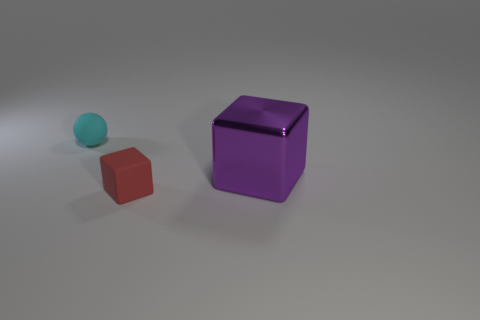How many matte things are tiny blue blocks or purple blocks? The image shows one tiny blue spherical object and one larger purple cube. If we are considering matte texture and the specific shapes as blocks, there are no tiny blue blocks. The purple object, while it is a block, is not tiny, hence the answer is 0. 